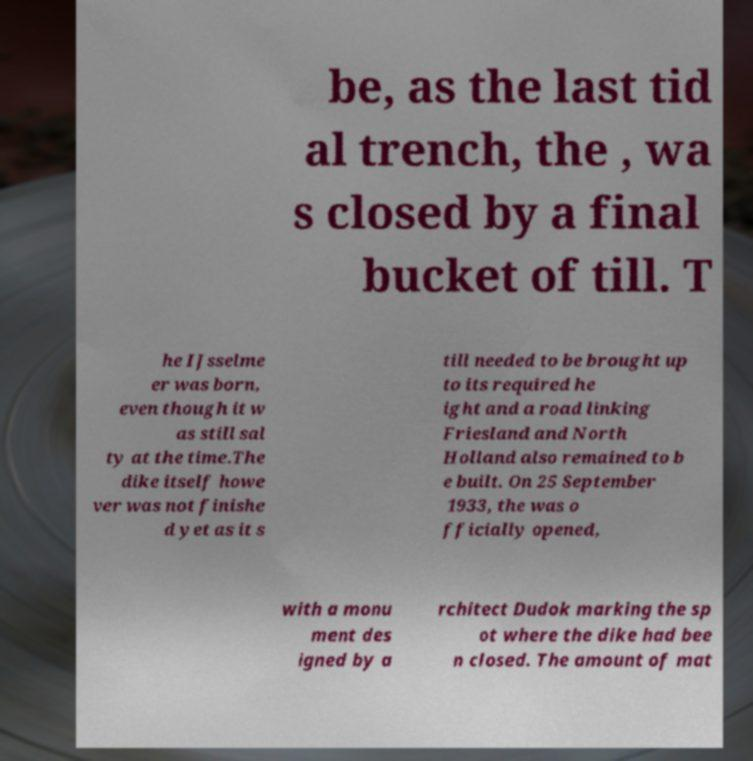What messages or text are displayed in this image? I need them in a readable, typed format. be, as the last tid al trench, the , wa s closed by a final bucket of till. T he IJsselme er was born, even though it w as still sal ty at the time.The dike itself howe ver was not finishe d yet as it s till needed to be brought up to its required he ight and a road linking Friesland and North Holland also remained to b e built. On 25 September 1933, the was o fficially opened, with a monu ment des igned by a rchitect Dudok marking the sp ot where the dike had bee n closed. The amount of mat 